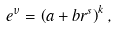<formula> <loc_0><loc_0><loc_500><loc_500>e ^ { \nu } = \left ( a + b r ^ { s } \right ) ^ { k } ,</formula> 